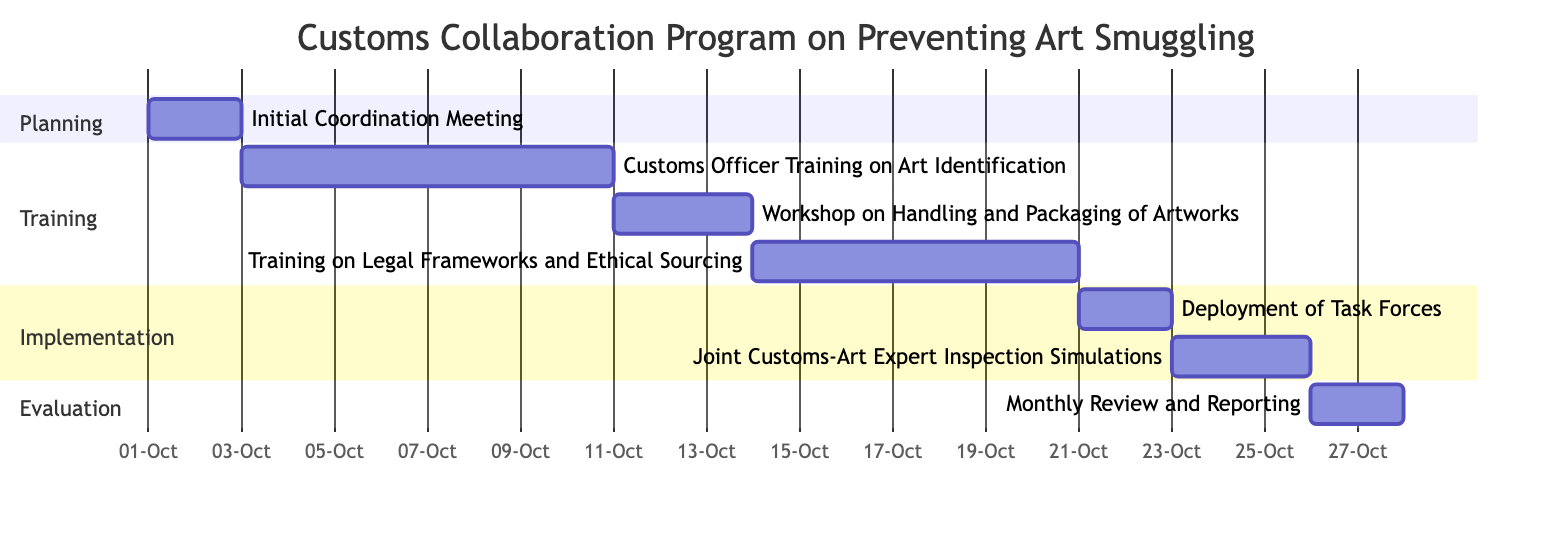What is the duration of the 'Workshop on Handling and Packaging of Artworks'? The workshop starts on October 11 and ends on October 13, spanning a total of 3 days.
Answer: 3 days What task follows the 'Customs Officer Training on Art Identification'? The training on Handling and Packaging of Artworks directly succeeds the Customs Officer Training, as indicated by the dependency relationship.
Answer: Workshop on Handling and Packaging of Artworks How many tasks are scheduled in the 'Implementation' section? There are two tasks outlined in the Implementation section: 'Deployment of Task Forces' and 'Joint Customs-Art Expert Inspection Simulations'.
Answer: 2 What is the start date of the 'Monthly Review and Reporting'? The Monthly Review and Reporting task begins on October 26, as indicated in the diagram.
Answer: October 26 Which task is the last one scheduled in this Gantt chart? The last task scheduled is the 'Monthly Review and Reporting', as it is the final task listed after all others.
Answer: Monthly Review and Reporting What is the relationship between the 'Training on Legal Frameworks and Ethical Sourcing' and 'Deployment of Task Forces'? The 'Deployment of Task Forces' depends on the completion of the 'Training on Legal Frameworks and Ethical Sourcing', as shown by the dependency relationship.
Answer: Dependency relationship How long does the 'Customs Officer Training on Art Identification' last? This training lasts for 8 days, from October 3 to October 10, covering the entire period indicated.
Answer: 8 days When does the 'Joint Customs-Art Expert Inspection Simulations' start? This task starts on October 23, as indicated by its start date in the diagram.
Answer: October 23 